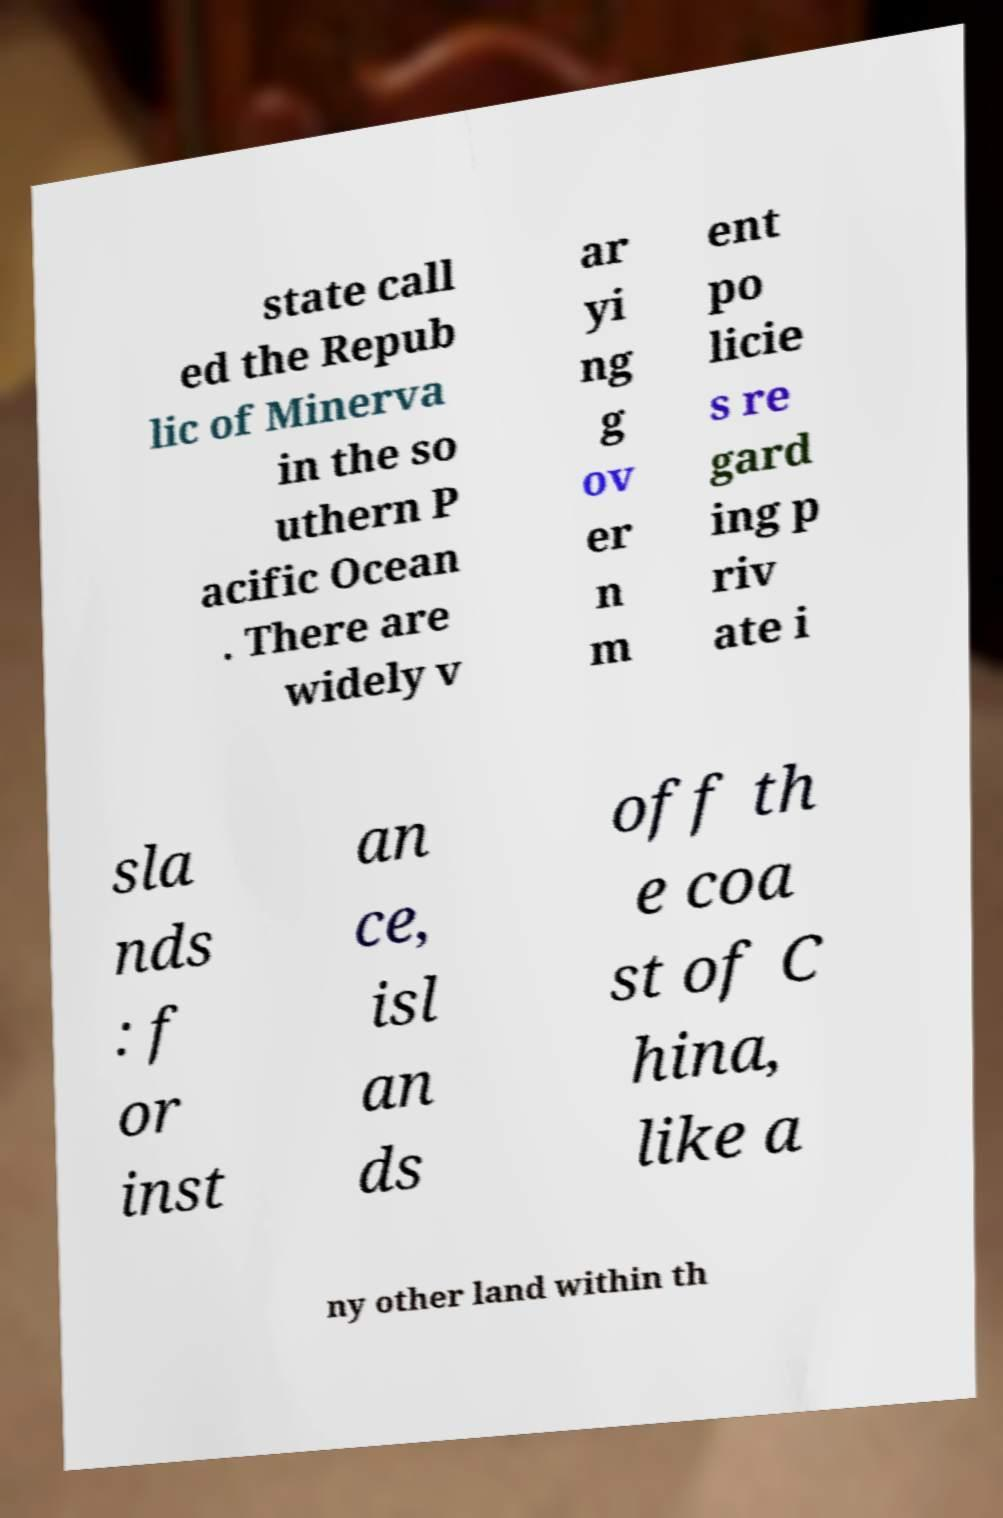Please read and relay the text visible in this image. What does it say? state call ed the Repub lic of Minerva in the so uthern P acific Ocean . There are widely v ar yi ng g ov er n m ent po licie s re gard ing p riv ate i sla nds : f or inst an ce, isl an ds off th e coa st of C hina, like a ny other land within th 